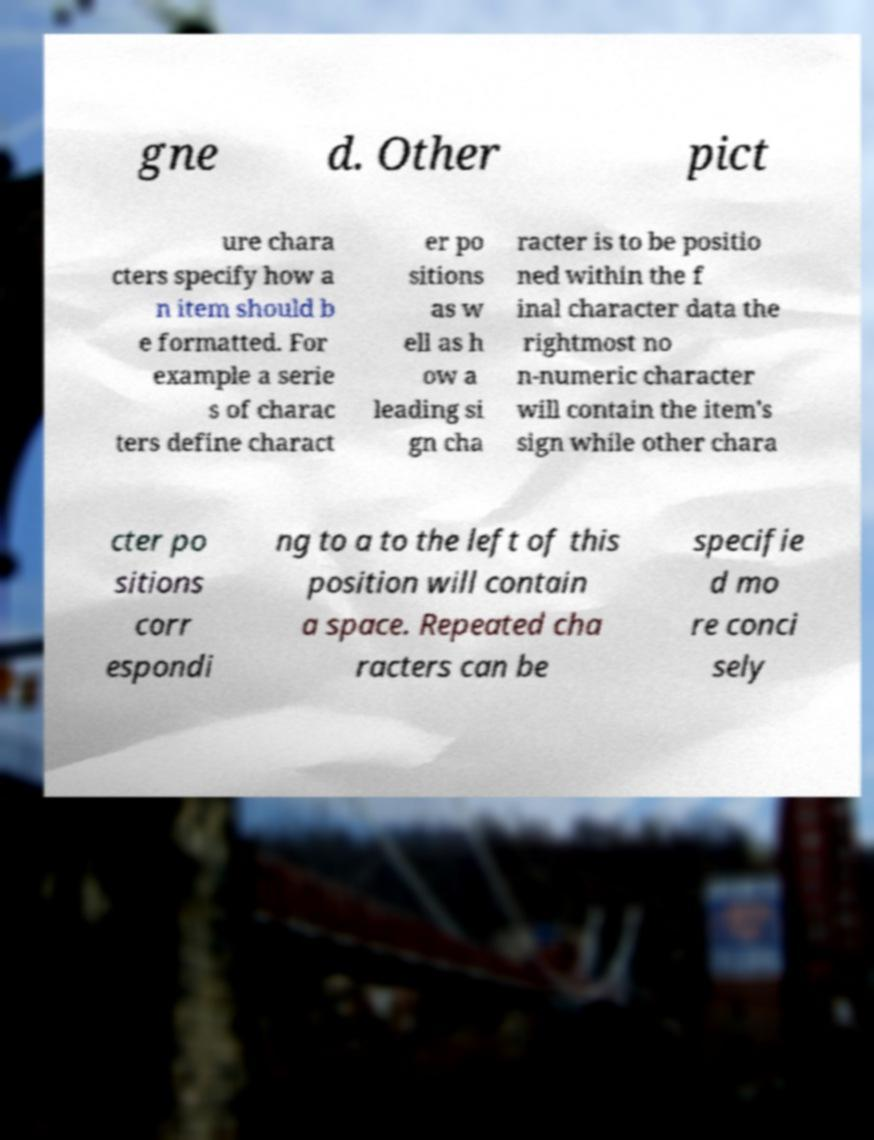Can you read and provide the text displayed in the image?This photo seems to have some interesting text. Can you extract and type it out for me? gne d. Other pict ure chara cters specify how a n item should b e formatted. For example a serie s of charac ters define charact er po sitions as w ell as h ow a leading si gn cha racter is to be positio ned within the f inal character data the rightmost no n-numeric character will contain the item's sign while other chara cter po sitions corr espondi ng to a to the left of this position will contain a space. Repeated cha racters can be specifie d mo re conci sely 